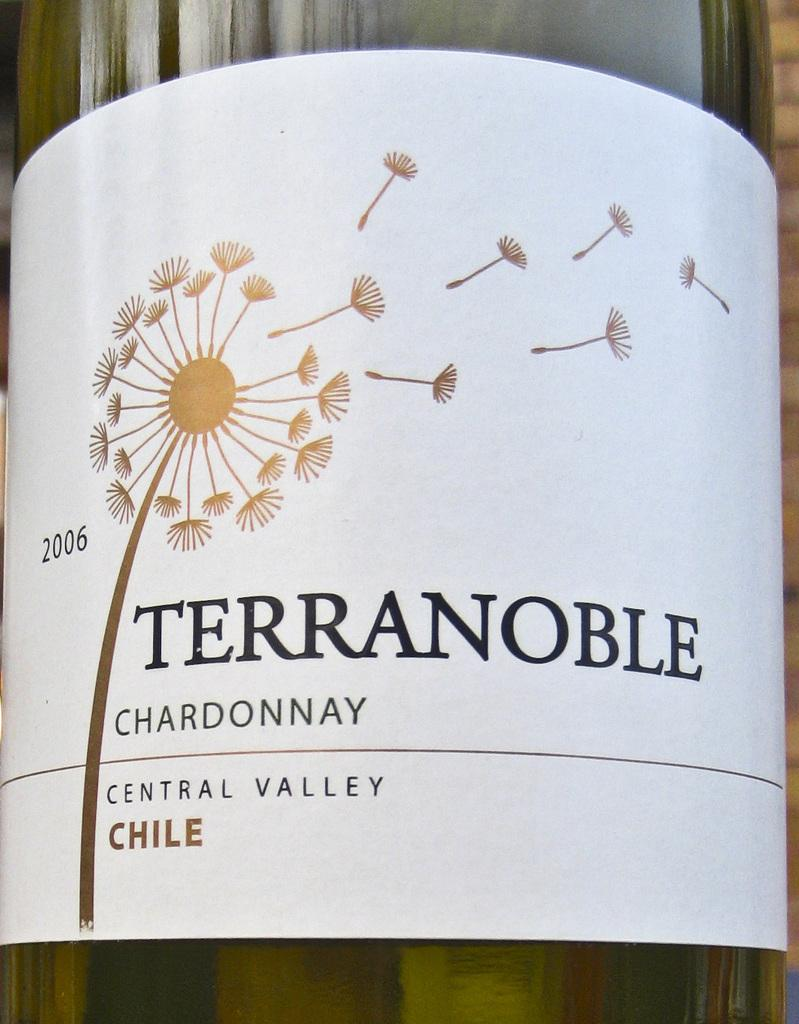<image>
Present a compact description of the photo's key features. the bottle of Terranoble is from Chile and has a white label 